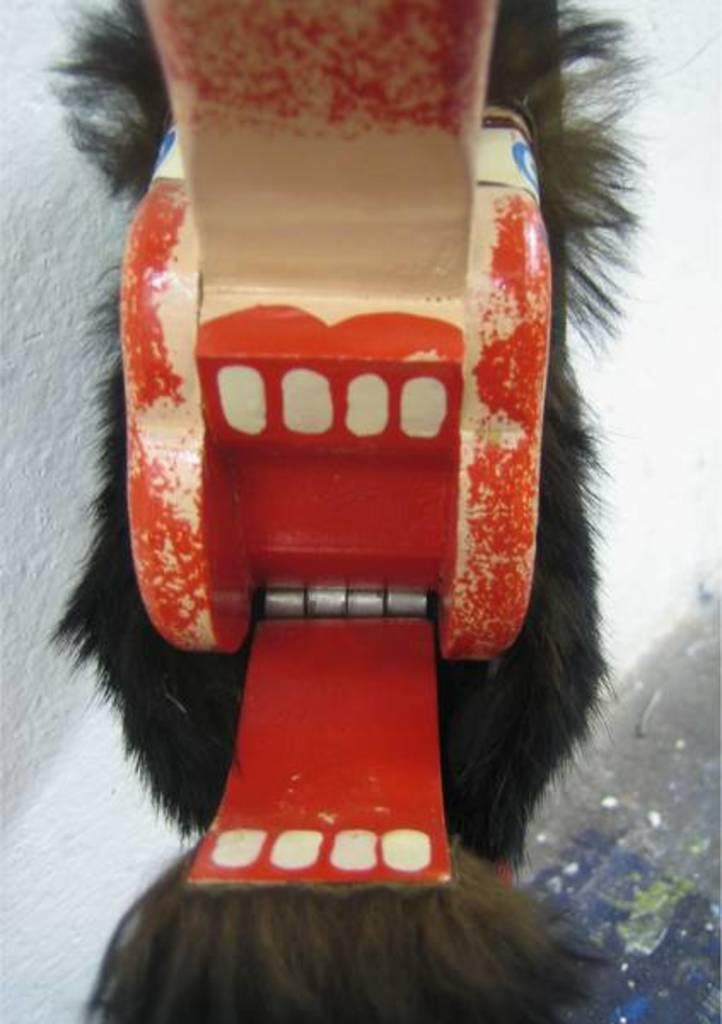What is the main subject in the middle of the image? There is a toy in the middle of the image. What can be seen in the background of the image? There is a wall in the background of the image. What is the color of the wall? The wall is white in color. Is there a servant standing next to the toy in the image? There is no servant present in the image; it only features a toy and a white wall in the background. 